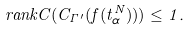<formula> <loc_0><loc_0><loc_500><loc_500>\ r a n k C ( C _ { \Gamma ^ { \prime } } ( f ( t _ { \alpha } ^ { N } ) ) ) \leq 1 .</formula> 